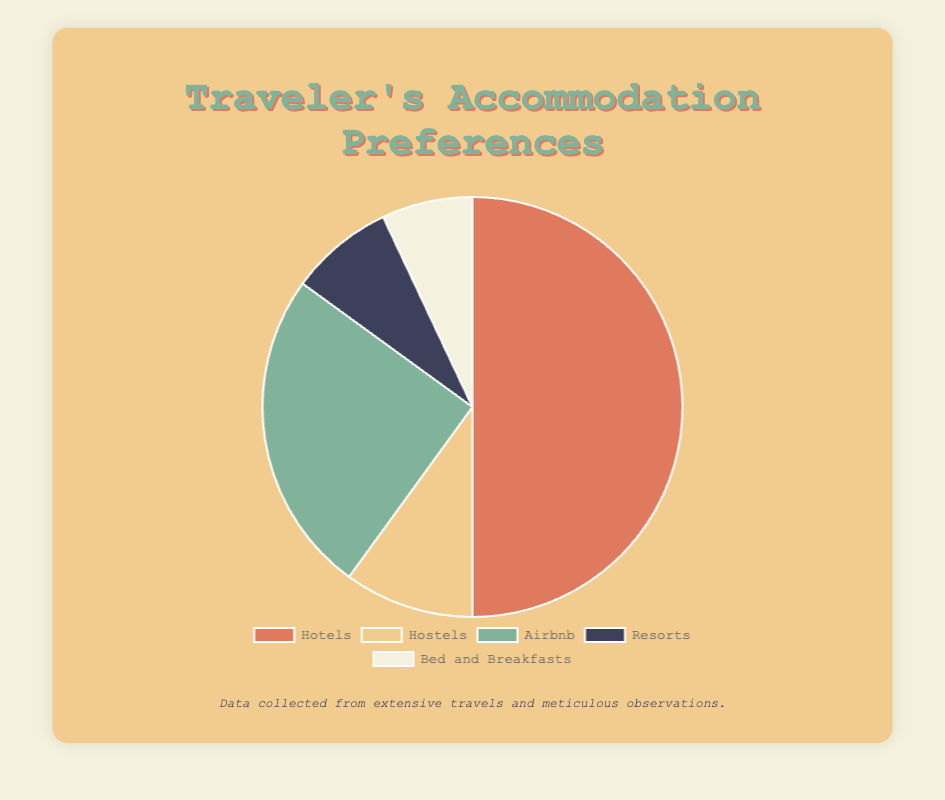Which type of accommodation has the highest preference among travelers? The pie chart shows five different accommodation types and their respective percentages. By examining the slices, the "Hotels" segment has the largest size, indicating the highest preference among travelers.
Answer: Hotels What is the total percentage of travelers who prefer Hostels and Resorts combined? To find the combined percentage of travelers preferring Hostels and Resorts, add the percentages for these two types: 10% (Hostels) + 8% (Resorts) = 18%.
Answer: 18% How does the preference for Airbnb compare to Bed and Breakfasts? The pie chart shows the percentage of travelers preferring each type of accommodation. Airbnb has a percentage of 25%, while Bed and Breakfasts have a percentage of 7%. Thus, Airbnb is more preferred compared to Bed and Breakfasts.
Answer: Airbnb is more preferred What percentage of travelers prefer either Hotels or Hostels? To find the total percentage of travelers who prefer either Hotels or Hostels, sum the percentages of these two accommodation types: 50% (Hotels) + 10% (Hostels) = 60%.
Answer: 60% Is the combined preference for Resorts and Bed and Breakfasts more than that for Airbnb? First, add the percentages for Resorts and Bed and Breakfasts: 8% (Resorts) + 7% (Bed and Breakfasts) = 15%. Next, compare this combined percentage to the percentage for Airbnb. Since 15% is less than 25%, the combined preference for Resorts and Bed and Breakfasts is not more than that for Airbnb.
Answer: No Which accommodation type has the smallest preference? By examining the pie chart, the smallest slice corresponds to the accommodation type with the smallest percentage. Bed and Breakfasts have a preference of 7%, which is the smallest among the given accommodation types.
Answer: Bed and Breakfasts What is the difference in percentage between the most and least preferred accommodation types? The most preferred type is Hotels at 50%, and the least preferred type is Bed and Breakfasts at 7%. The difference in percentage is calculated as 50% - 7% = 43%.
Answer: 43% Is the preference for Resorts closer to that for Hostels or Bed and Breakfasts? The percentage for Resorts is 8%. Compared to Hostels (10%) and Bed and Breakfasts (7%), Resorts are closer to Bed and Breakfasts since the difference is smaller: 1% (8% - 7%) vs. 2% (10% - 8%).
Answer: Bed and Breakfasts 